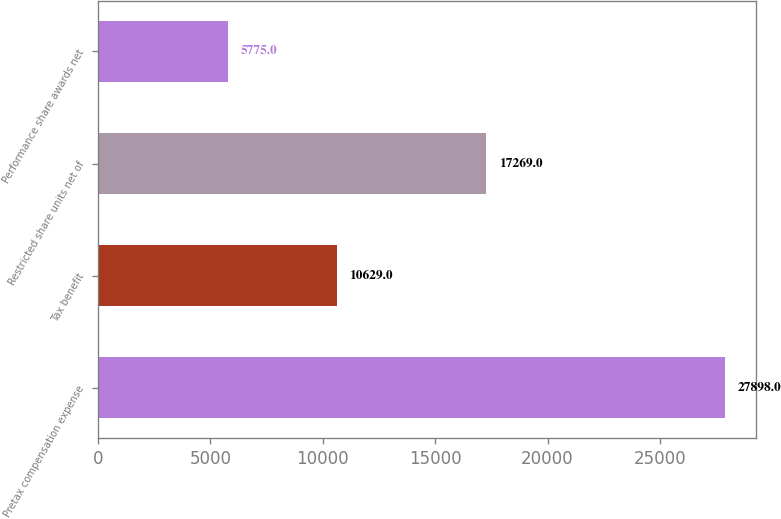Convert chart to OTSL. <chart><loc_0><loc_0><loc_500><loc_500><bar_chart><fcel>Pretax compensation expense<fcel>Tax benefit<fcel>Restricted share units net of<fcel>Performance share awards net<nl><fcel>27898<fcel>10629<fcel>17269<fcel>5775<nl></chart> 